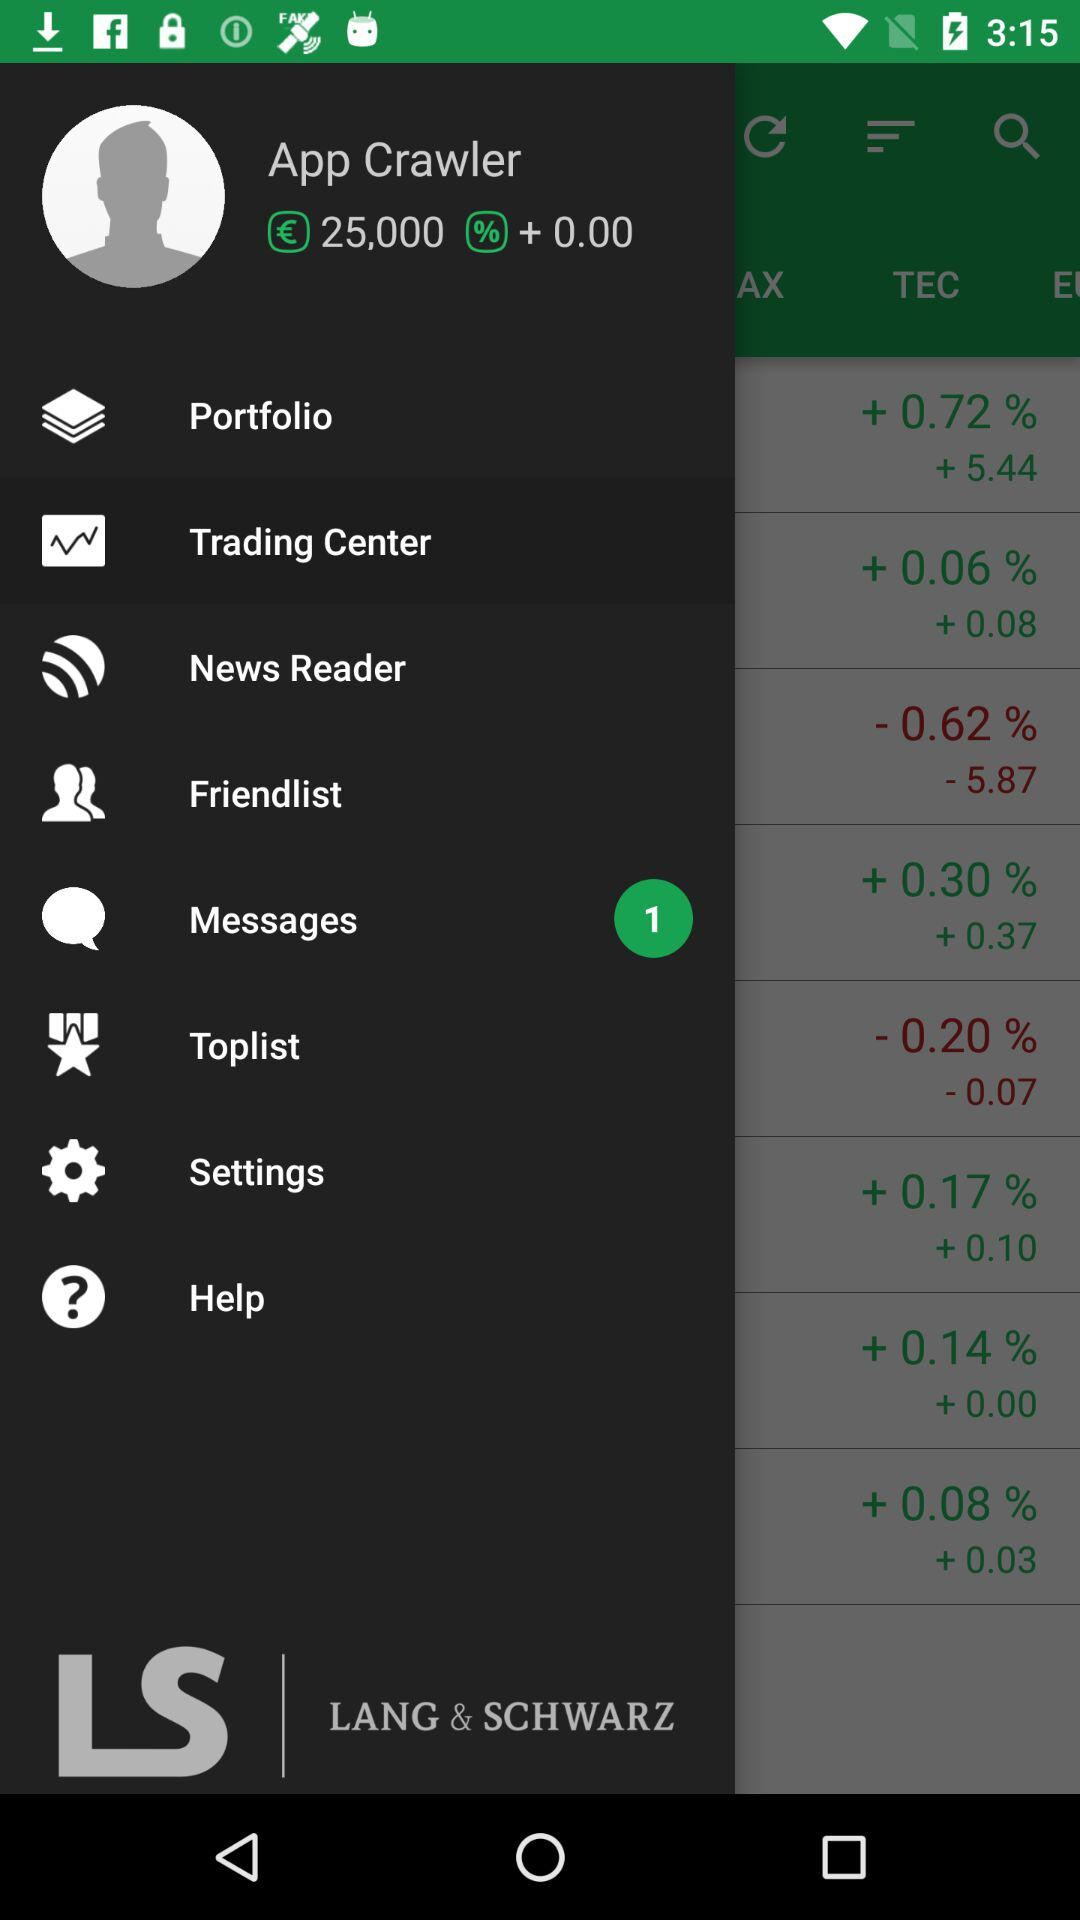What is the name? The name is "App Crawler". 